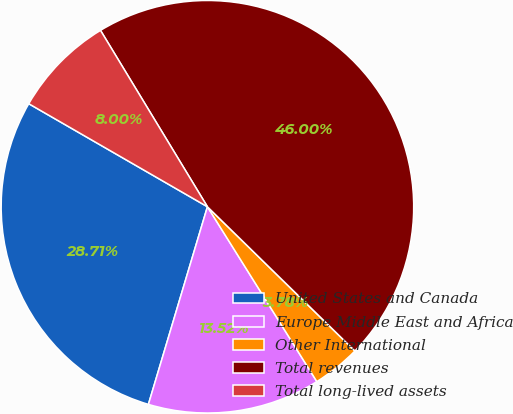Convert chart. <chart><loc_0><loc_0><loc_500><loc_500><pie_chart><fcel>United States and Canada<fcel>Europe Middle East and Africa<fcel>Other International<fcel>Total revenues<fcel>Total long-lived assets<nl><fcel>28.71%<fcel>13.52%<fcel>3.78%<fcel>46.0%<fcel>8.0%<nl></chart> 